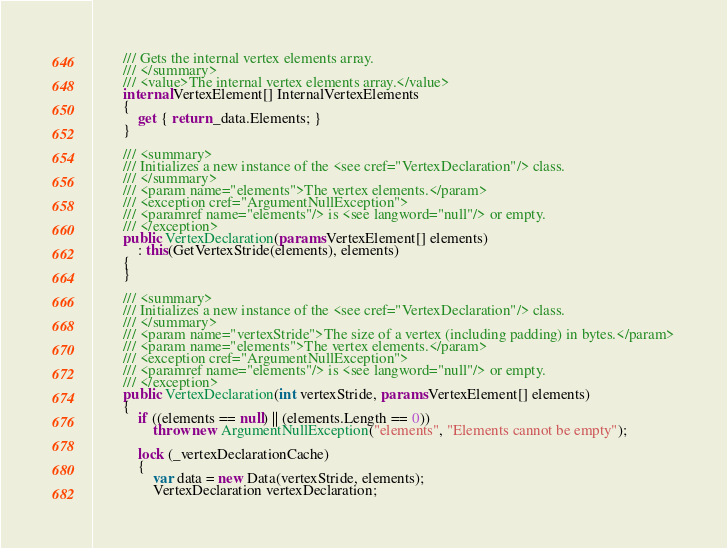<code> <loc_0><loc_0><loc_500><loc_500><_C#_>        /// Gets the internal vertex elements array.
        /// </summary>
        /// <value>The internal vertex elements array.</value>
        internal VertexElement[] InternalVertexElements
        {
            get { return _data.Elements; }
        }

        /// <summary>
        /// Initializes a new instance of the <see cref="VertexDeclaration"/> class.
        /// </summary>
        /// <param name="elements">The vertex elements.</param>
        /// <exception cref="ArgumentNullException">
        /// <paramref name="elements"/> is <see langword="null"/> or empty.
        /// </exception>
        public VertexDeclaration(params VertexElement[] elements)
            : this(GetVertexStride(elements), elements)
		{
		}

        /// <summary>
        /// Initializes a new instance of the <see cref="VertexDeclaration"/> class.
        /// </summary>
        /// <param name="vertexStride">The size of a vertex (including padding) in bytes.</param>
        /// <param name="elements">The vertex elements.</param>
        /// <exception cref="ArgumentNullException">
        /// <paramref name="elements"/> is <see langword="null"/> or empty.
        /// </exception>
        public VertexDeclaration(int vertexStride, params VertexElement[] elements)
        {
            if ((elements == null) || (elements.Length == 0))
                throw new ArgumentNullException("elements", "Elements cannot be empty");

            lock (_vertexDeclarationCache)
            {
                var data = new Data(vertexStride, elements);
                VertexDeclaration vertexDeclaration;</code> 